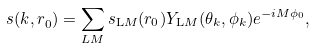<formula> <loc_0><loc_0><loc_500><loc_500>s ( { k , r } _ { 0 } ) = \sum _ { L M } { s _ { \mathrm L M } ( r _ { 0 } ) Y _ { \mathrm L M } ( \theta _ { k } , \phi _ { k } ) e ^ { - i M \phi _ { 0 } } } ,</formula> 